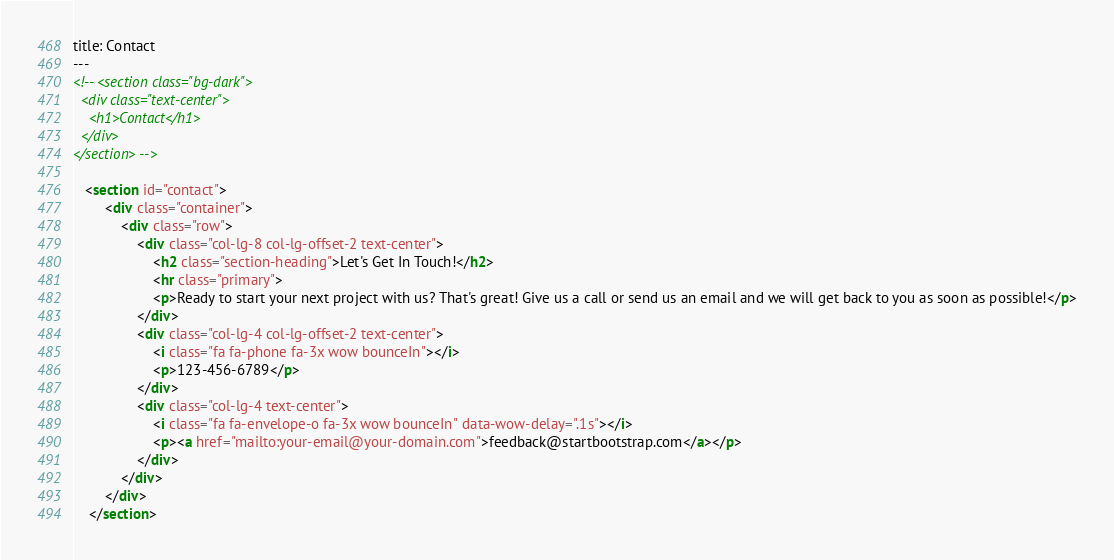<code> <loc_0><loc_0><loc_500><loc_500><_HTML_>title: Contact
---
<!-- <section class="bg-dark">
  <div class="text-center">
    <h1>Contact</h1>
  </div>
</section> -->

   <section id="contact">
        <div class="container">
            <div class="row">
                <div class="col-lg-8 col-lg-offset-2 text-center">
                    <h2 class="section-heading">Let's Get In Touch!</h2>
                    <hr class="primary">
                    <p>Ready to start your next project with us? That's great! Give us a call or send us an email and we will get back to you as soon as possible!</p>
                </div>
                <div class="col-lg-4 col-lg-offset-2 text-center">
                    <i class="fa fa-phone fa-3x wow bounceIn"></i>
                    <p>123-456-6789</p>
                </div>
                <div class="col-lg-4 text-center">
                    <i class="fa fa-envelope-o fa-3x wow bounceIn" data-wow-delay=".1s"></i>
                    <p><a href="mailto:your-email@your-domain.com">feedback@startbootstrap.com</a></p>
                </div>
            </div>
        </div>
    </section></code> 